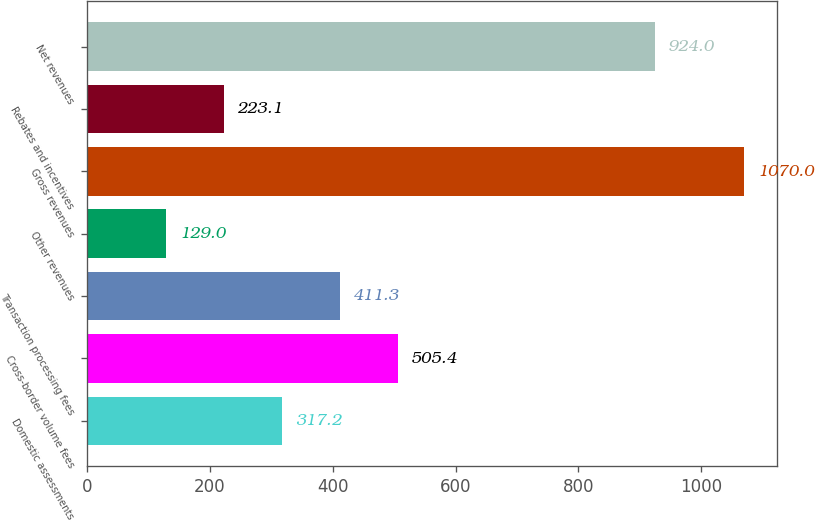<chart> <loc_0><loc_0><loc_500><loc_500><bar_chart><fcel>Domestic assessments<fcel>Cross-border volume fees<fcel>Transaction processing fees<fcel>Other revenues<fcel>Gross revenues<fcel>Rebates and incentives<fcel>Net revenues<nl><fcel>317.2<fcel>505.4<fcel>411.3<fcel>129<fcel>1070<fcel>223.1<fcel>924<nl></chart> 